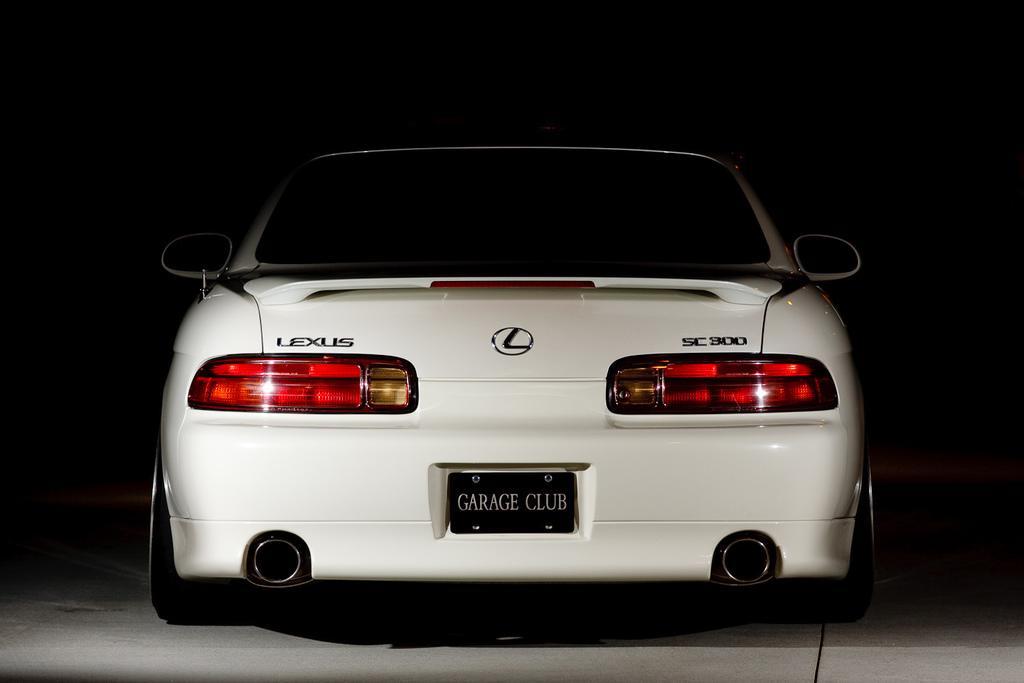Describe this image in one or two sentences. This is a car, which is white in color. I can see a registration plate, tail lights, logo, vehicle silencers, side mirrors, wheels and other objects are attached to a car. The background looks dark. 